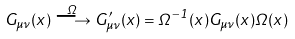<formula> <loc_0><loc_0><loc_500><loc_500>G _ { \mu \nu } ( x ) \stackrel { \Omega } { \longrightarrow } G ^ { \prime } _ { \mu \nu } ( x ) = \Omega ^ { - 1 } ( x ) G _ { \mu \nu } ( x ) \Omega ( x )</formula> 